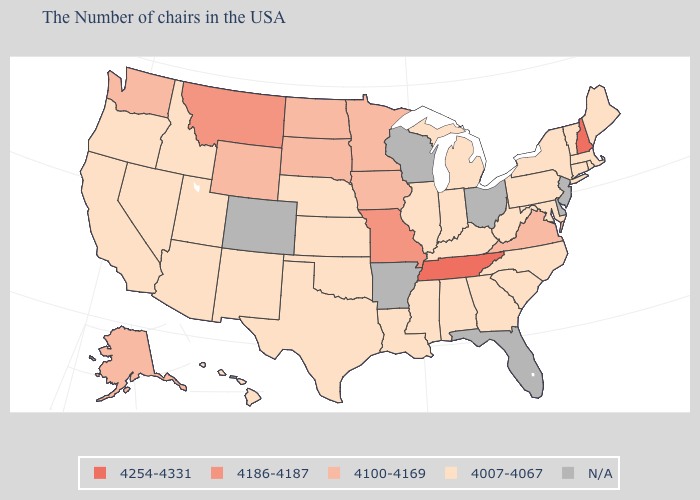What is the lowest value in states that border Maine?
Give a very brief answer. 4254-4331. Name the states that have a value in the range 4100-4169?
Keep it brief. Virginia, Minnesota, Iowa, South Dakota, North Dakota, Wyoming, Washington, Alaska. Name the states that have a value in the range 4007-4067?
Concise answer only. Maine, Massachusetts, Rhode Island, Vermont, Connecticut, New York, Maryland, Pennsylvania, North Carolina, South Carolina, West Virginia, Georgia, Michigan, Kentucky, Indiana, Alabama, Illinois, Mississippi, Louisiana, Kansas, Nebraska, Oklahoma, Texas, New Mexico, Utah, Arizona, Idaho, Nevada, California, Oregon, Hawaii. Name the states that have a value in the range 4007-4067?
Be succinct. Maine, Massachusetts, Rhode Island, Vermont, Connecticut, New York, Maryland, Pennsylvania, North Carolina, South Carolina, West Virginia, Georgia, Michigan, Kentucky, Indiana, Alabama, Illinois, Mississippi, Louisiana, Kansas, Nebraska, Oklahoma, Texas, New Mexico, Utah, Arizona, Idaho, Nevada, California, Oregon, Hawaii. What is the lowest value in states that border Rhode Island?
Write a very short answer. 4007-4067. Name the states that have a value in the range 4186-4187?
Be succinct. Missouri, Montana. Is the legend a continuous bar?
Keep it brief. No. What is the value of Oklahoma?
Write a very short answer. 4007-4067. What is the value of New Mexico?
Quick response, please. 4007-4067. Name the states that have a value in the range 4007-4067?
Write a very short answer. Maine, Massachusetts, Rhode Island, Vermont, Connecticut, New York, Maryland, Pennsylvania, North Carolina, South Carolina, West Virginia, Georgia, Michigan, Kentucky, Indiana, Alabama, Illinois, Mississippi, Louisiana, Kansas, Nebraska, Oklahoma, Texas, New Mexico, Utah, Arizona, Idaho, Nevada, California, Oregon, Hawaii. Name the states that have a value in the range N/A?
Concise answer only. New Jersey, Delaware, Ohio, Florida, Wisconsin, Arkansas, Colorado. Name the states that have a value in the range N/A?
Be succinct. New Jersey, Delaware, Ohio, Florida, Wisconsin, Arkansas, Colorado. What is the value of New Mexico?
Short answer required. 4007-4067. What is the highest value in states that border Missouri?
Write a very short answer. 4254-4331. Name the states that have a value in the range N/A?
Concise answer only. New Jersey, Delaware, Ohio, Florida, Wisconsin, Arkansas, Colorado. 